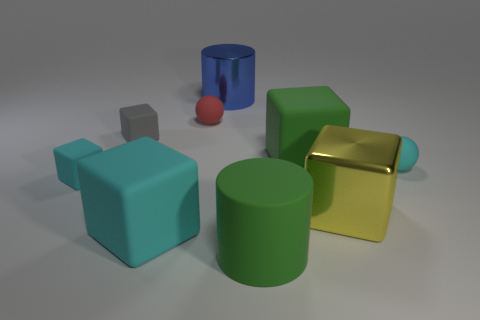Subtract 1 blocks. How many blocks are left? 4 Subtract all purple blocks. Subtract all green spheres. How many blocks are left? 5 Subtract all cylinders. How many objects are left? 7 Subtract all big yellow metallic cubes. Subtract all tiny cyan objects. How many objects are left? 6 Add 1 gray cubes. How many gray cubes are left? 2 Add 6 gray objects. How many gray objects exist? 7 Subtract 0 blue blocks. How many objects are left? 9 